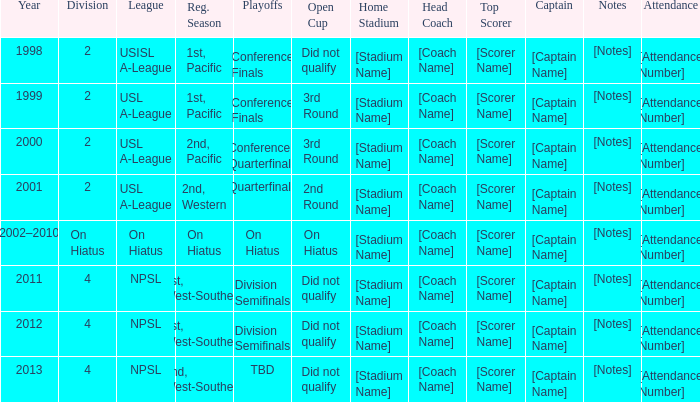Which playoffs took place during 2011? Division Semifinals. 